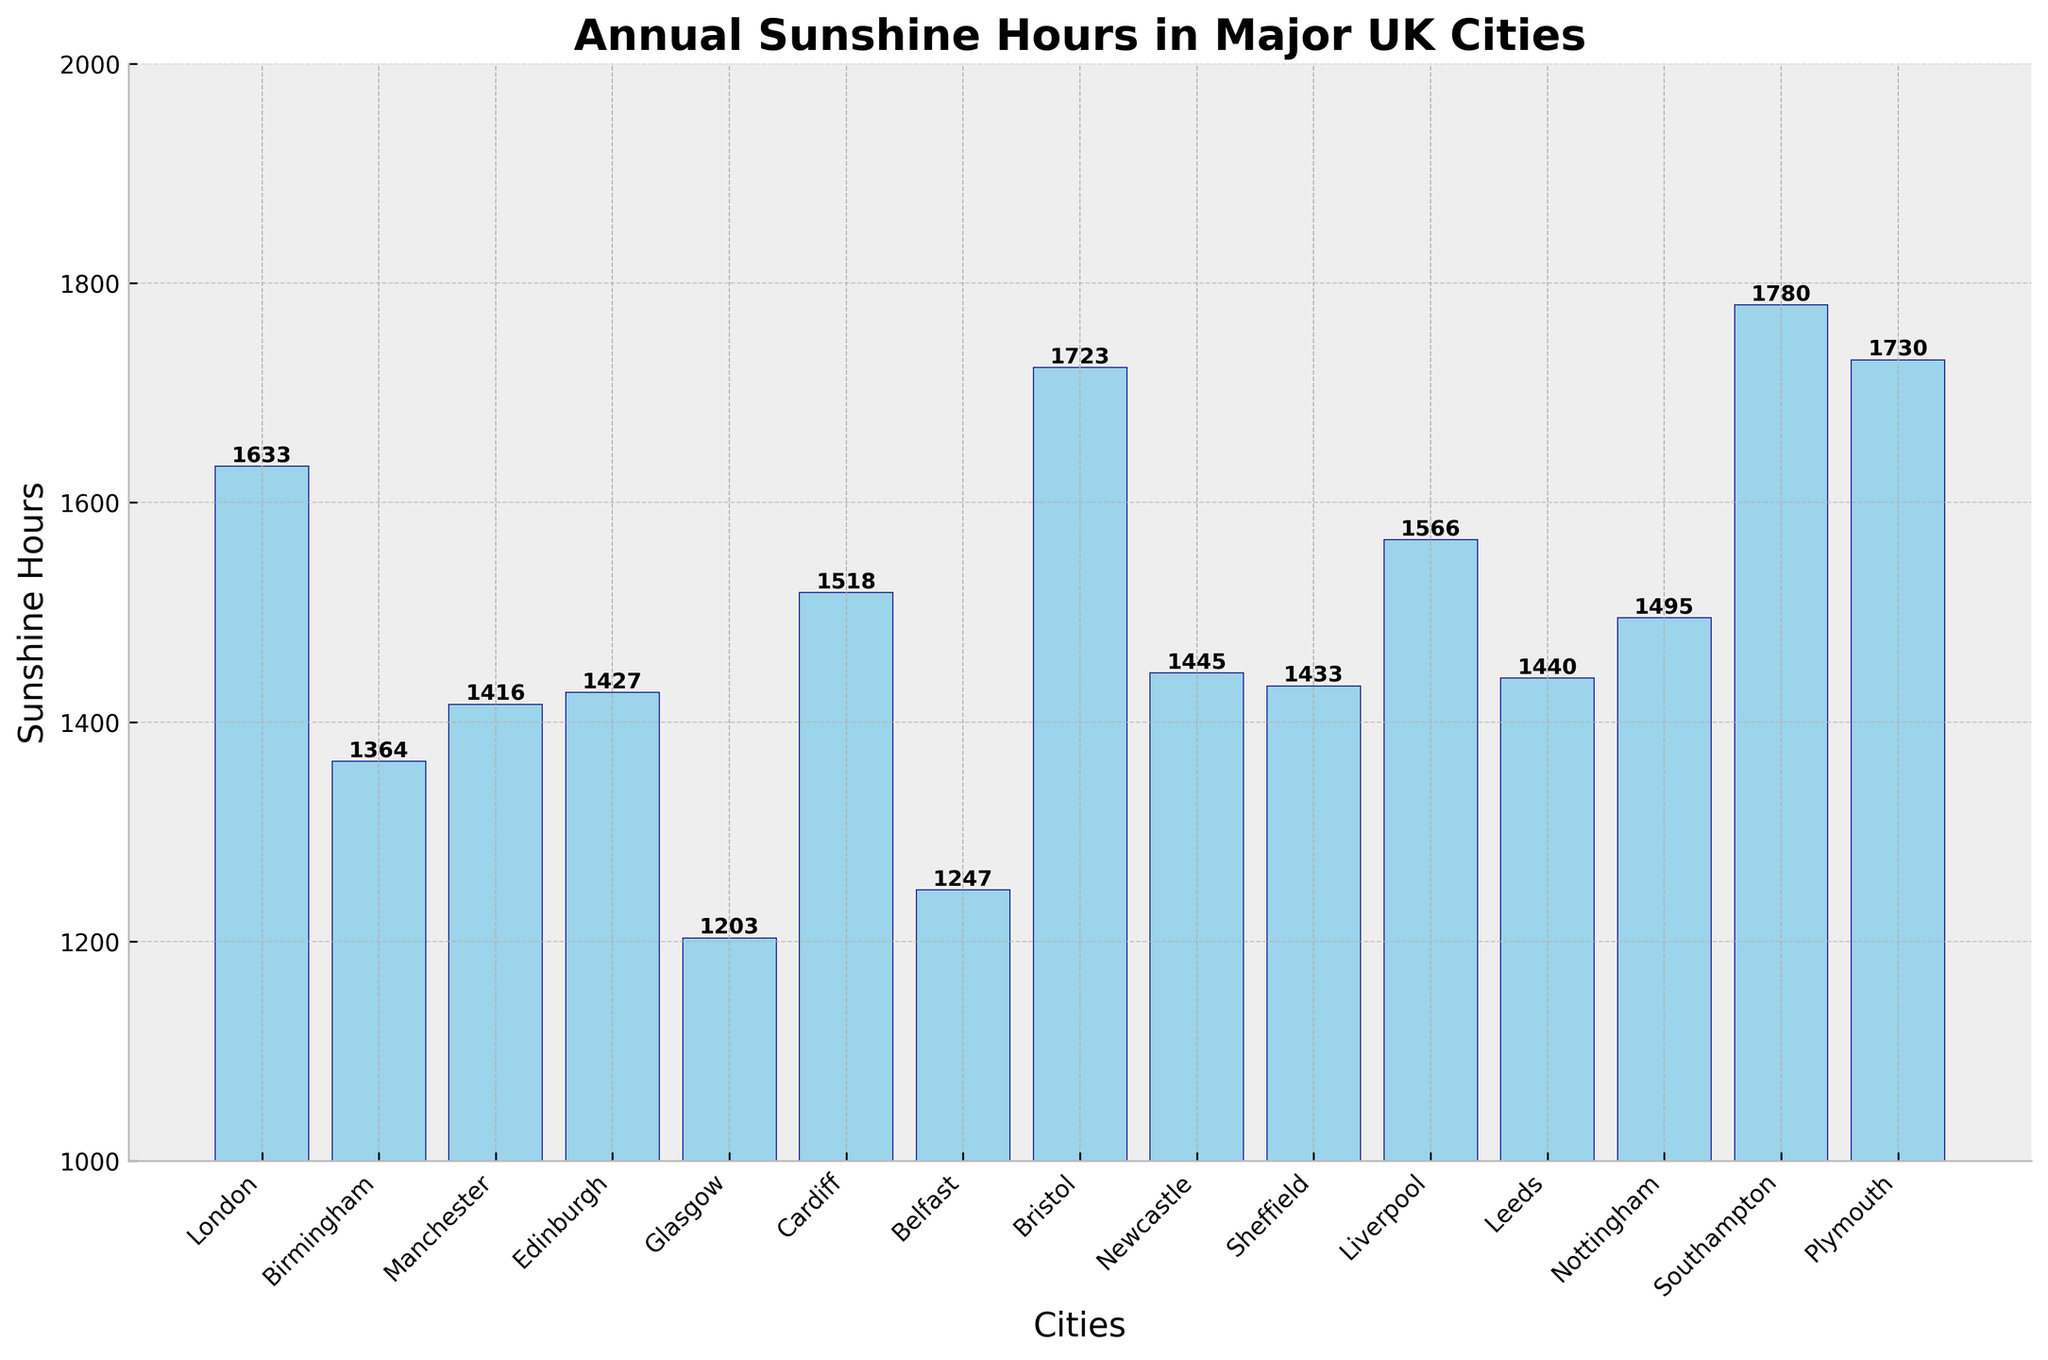Which city has the highest annual sunshine hours? By visually inspecting the bar chart, the bar representing Southampton reaches the highest point, indicating the most sunshine hours.
Answer: Southampton What is the difference in annual sunshine hours between Birmingham and Bristol? Identify the height of the bars representing Birmingham and Bristol. Birmingham has 1364 hours, and Bristol has 1723 hours. Subtract Birmingham's total from Bristol's to find the difference: 1723 - 1364 = 359.
Answer: 359 Which cities have annual sunshine hours between 1400 and 1600? Look at the bars whose heights fall within the range of 1400 to 1600 hours. These bars correspond to the cities of Manchester (1416), Edinburgh (1427), Sheffield (1433), Newcastle (1445), Leeds (1440), Nottingham (1495), and Liverpool (1566).
Answer: Manchester, Edinburgh, Sheffield, Newcastle, Leeds, Nottingham, Liverpool If you sum the annual sunshine hours of Leeds, Glasgow, and Edinburgh, what is the total? First, locate the bars for Leeds (1440), Glasgow (1203), and Edinburgh (1427). Then, add their values together: 1440 + 1203 + 1427 = 4070.
Answer: 4070 How many more sunshine hours does London receive compared to Belfast? Find the difference in their bar heights: London has 1633 hours, and Belfast has 1247 hours. Subtract Belfast's total from London's: 1633 - 1247 = 386.
Answer: 386 Which city has the lowest annual sunshine hours, and what is its value? The smallest bar by height represents Glasgow, indicating it has the lowest annual sunshine hours at 1203.
Answer: Glasgow, 1203 Which city receives more sunshine hours, Cardiff or Liverpool? Compare the height of the bars for Cardiff (1518) and Liverpool (1566). Liverpool's bar is taller, indicating more sunshine hours.
Answer: Liverpool What's the average annual sunshine hours for Edinburgh, Glasgow, and Belfast? Sum up the sunshine hours of Edinburgh (1427), Glasgow (1203), and Belfast (1247) which gives us 1427 + 1203 + 1247 = 3877. Divide this total by 3 to find the average: 3877 / 3 ≈ 1292.33.
Answer: 1292.33 By how many hours do Newcastle's annual sunshine hours exceed Sheffield's? Compare the bars for Newcastle (1445) and Sheffield (1433). Subtract Sheffield's total from Newcastle's: 1445 - 1433 = 12.
Answer: 12 